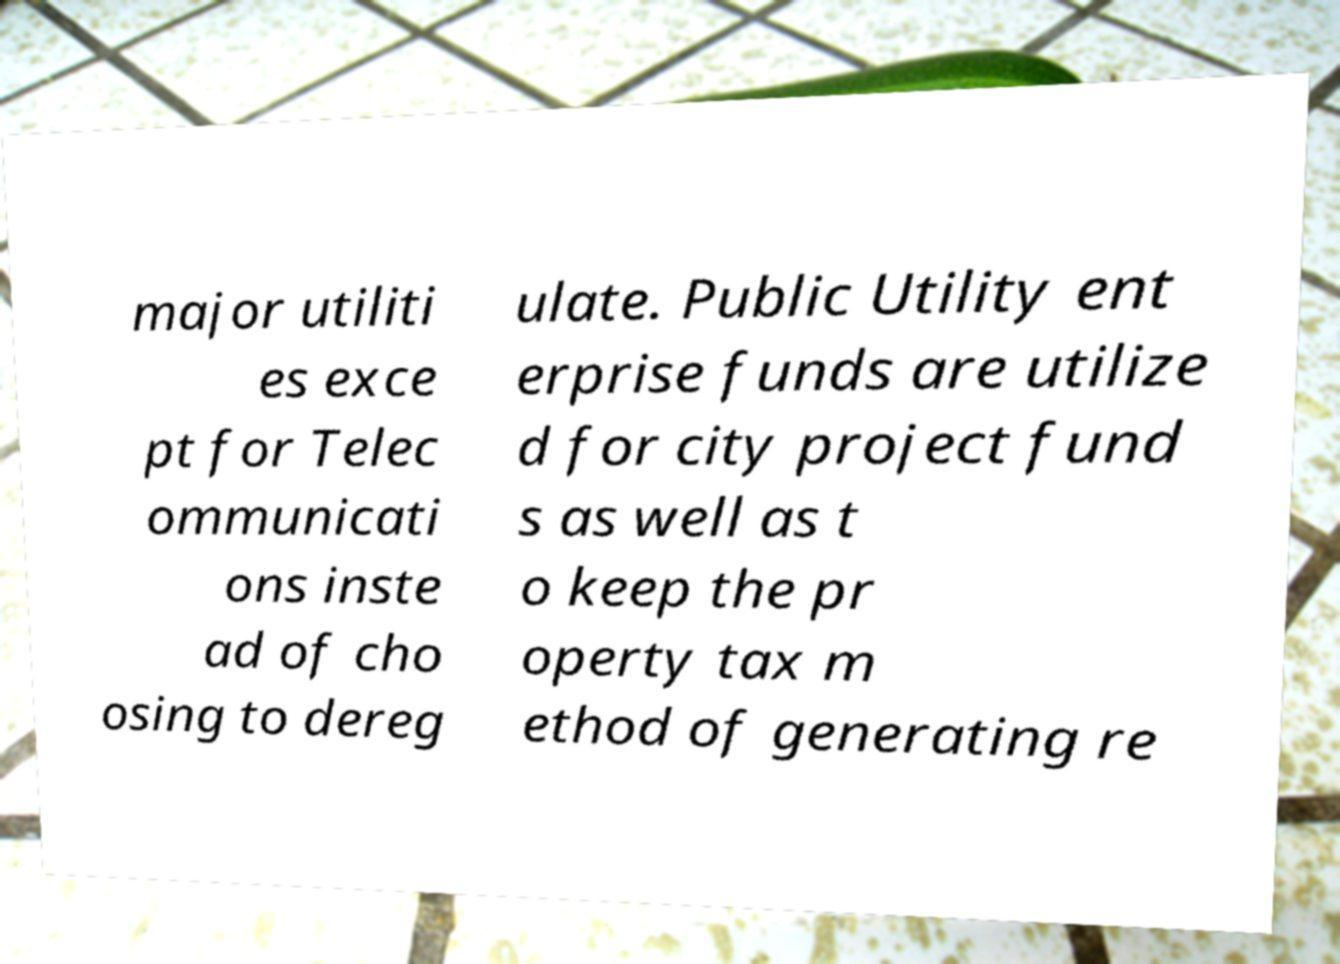I need the written content from this picture converted into text. Can you do that? major utiliti es exce pt for Telec ommunicati ons inste ad of cho osing to dereg ulate. Public Utility ent erprise funds are utilize d for city project fund s as well as t o keep the pr operty tax m ethod of generating re 